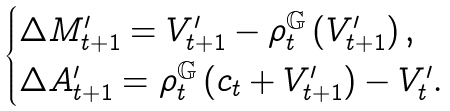<formula> <loc_0><loc_0><loc_500><loc_500>\begin{cases} \Delta M ^ { \prime } _ { t + 1 } = V ^ { \prime } _ { t + 1 } - \rho ^ { \mathbb { G } } _ { t } \left ( V ^ { \prime } _ { t + 1 } \right ) , \\ \Delta A ^ { \prime } _ { t + 1 } = \rho ^ { \mathbb { G } } _ { t } \left ( c _ { t } + V ^ { \prime } _ { t + 1 } \right ) - V ^ { \prime } _ { t } . \end{cases}</formula> 